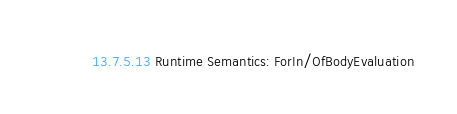Convert code to text. <code><loc_0><loc_0><loc_500><loc_500><_JavaScript_>
    13.7.5.13 Runtime Semantics: ForIn/OfBodyEvaluation
</code> 